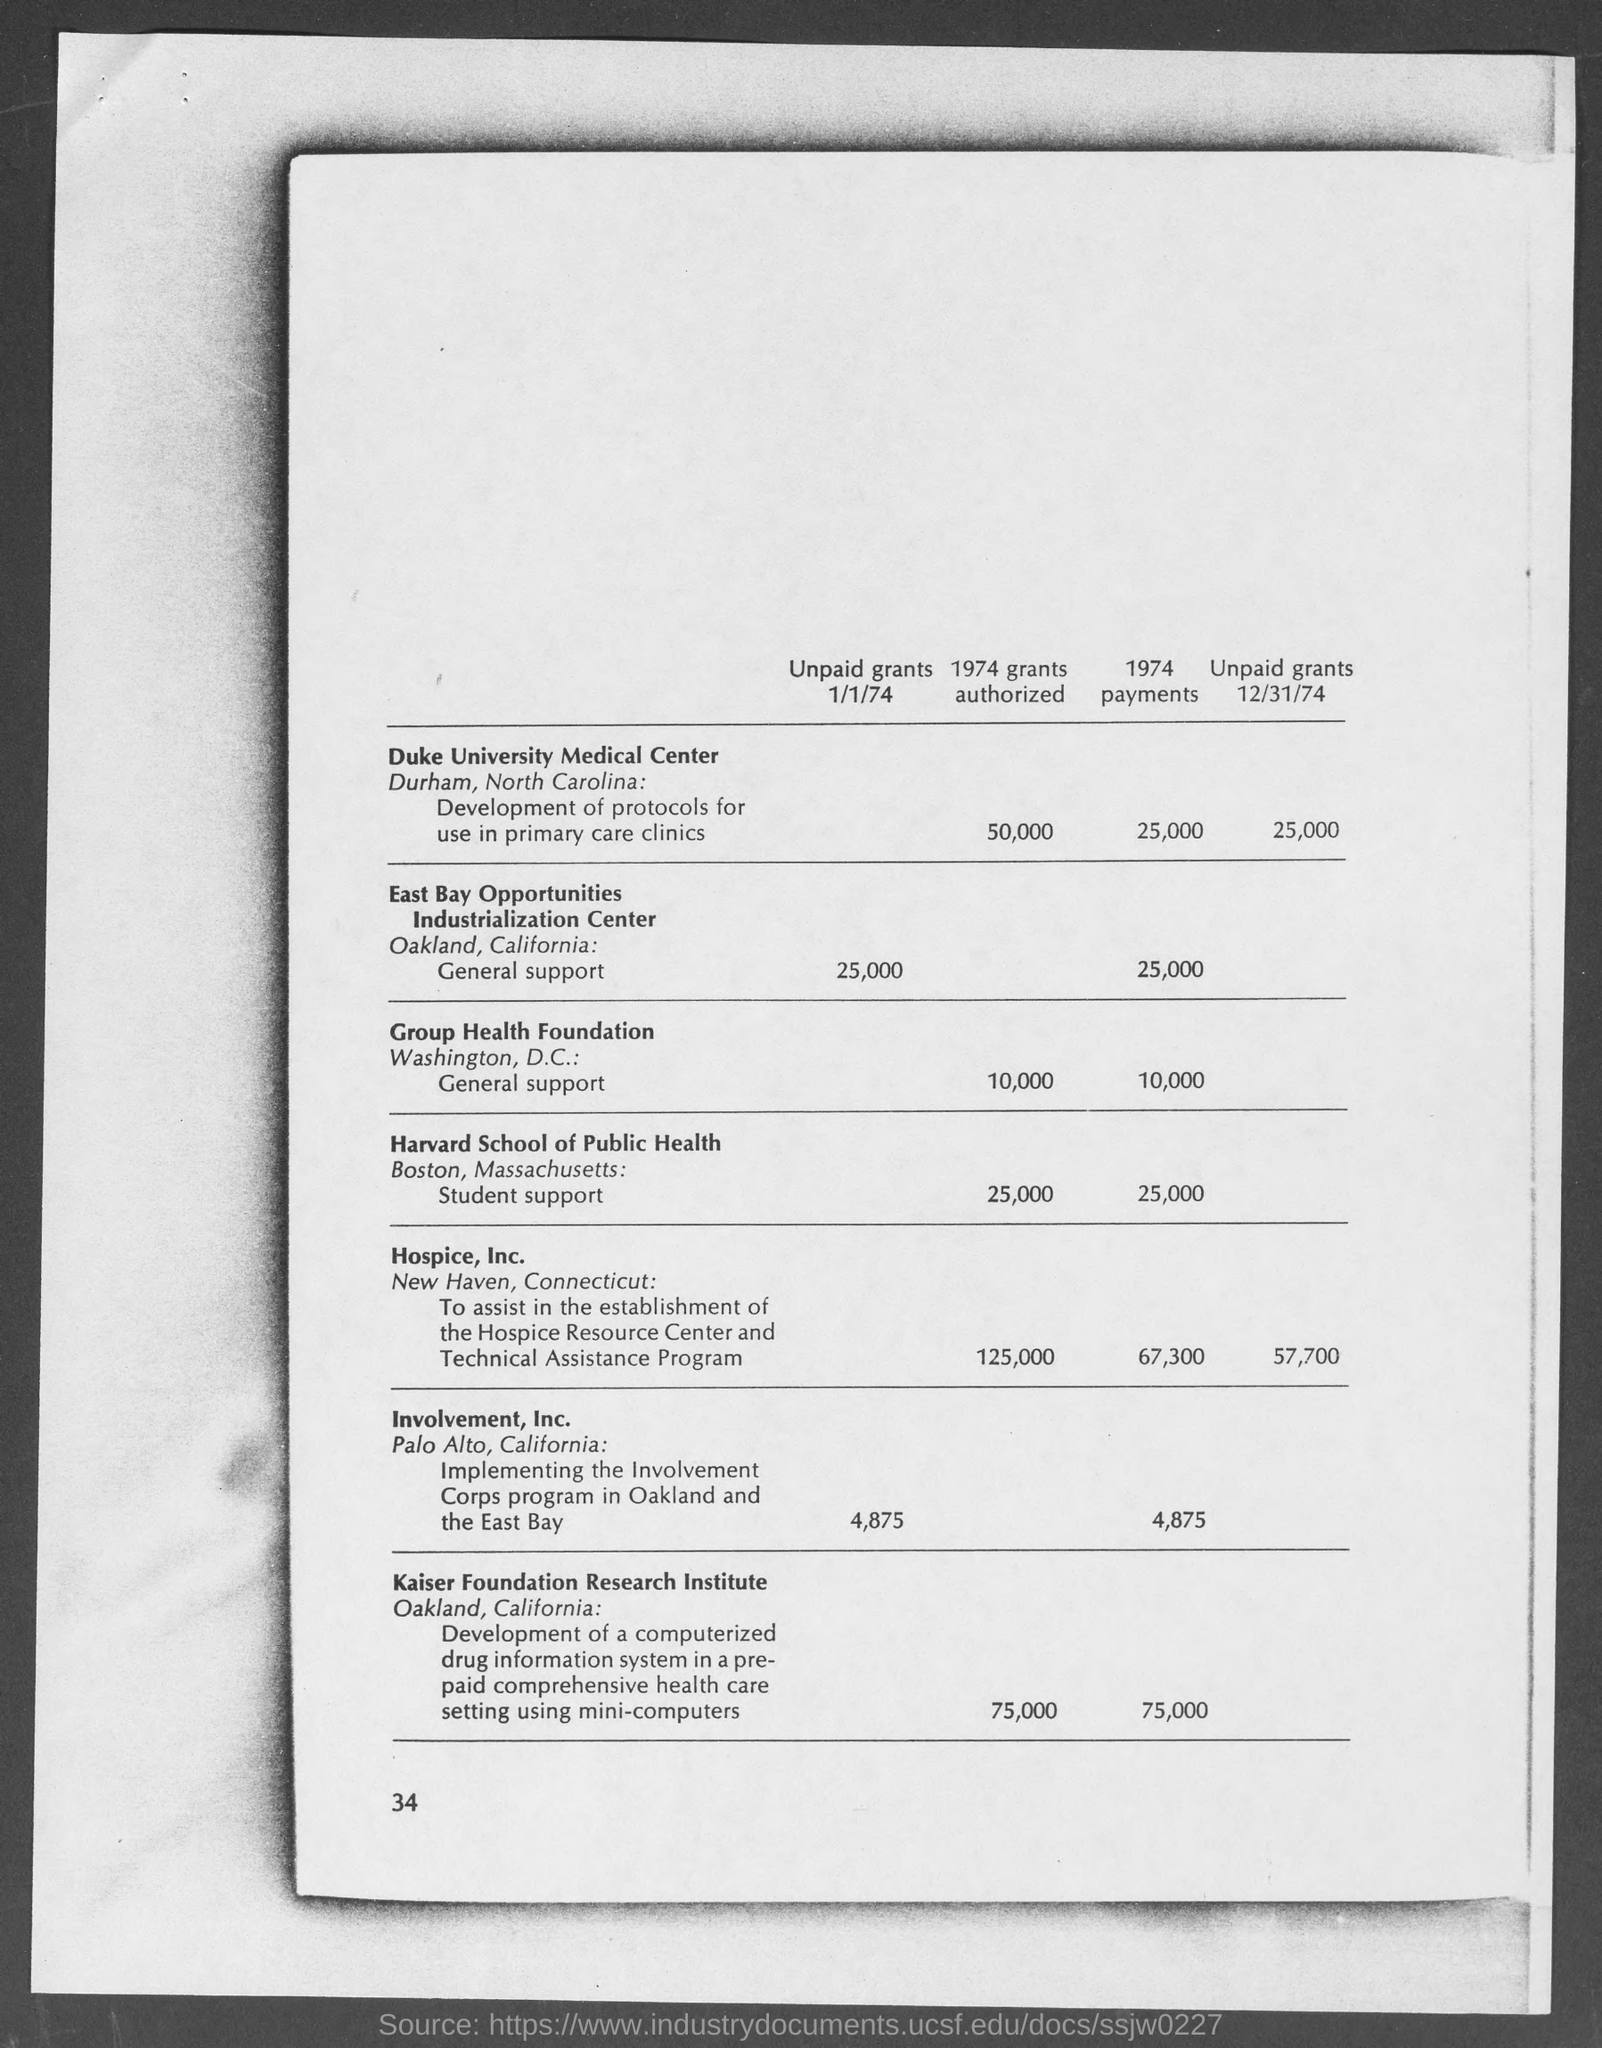Highlight a few significant elements in this photo. Harvard School of Public Health is located in Boston, Massachusetts. Hospice, inc. is located in New Haven, the city where it resides. The East Bay Opportunities Industrialization Center is located in the city of Oakland. The number located at the bottom-left corner of the page is 34. In Palo Alto, the location of Involvement, inc, is the city where the company is located. 